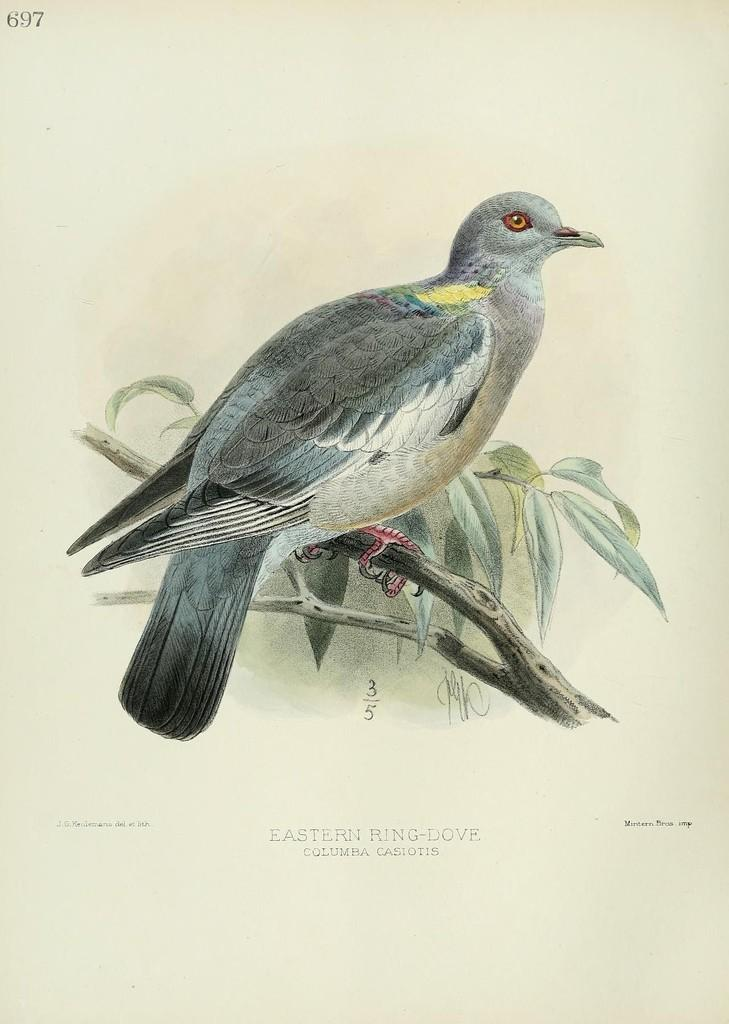What is depicted in the painting in the image? There is a painting of a bird in the image. Where is the bird located in the painting? The bird is on a stream in the painting. What additional information can be found at the bottom of the image? There is text at the bottom of the image. What type of straw is being used to cut the bird in the image? There is no straw or scissors present in the image, and the bird is not being cut. Is the painting of the bird a work of fiction or non-fiction? The painting of the bird is a work of art and not classified as fiction or non-fiction. 